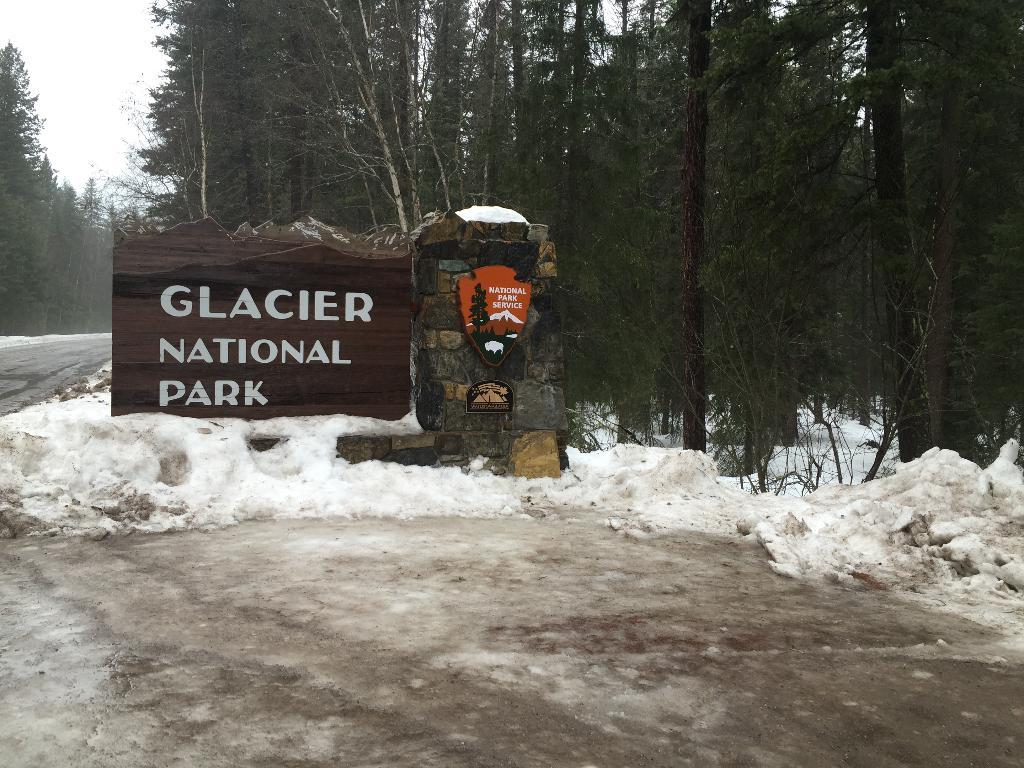What can be seen in abundance in the image? There are many trees in the image. What information is displayed in the image? The name of the park board is visible. What architectural feature is present in the image? There is a pillar in the image. What type of pathway is present in the image? A road is present in the image. What weather condition is depicted in the image? Snow is visible in the image. What part of the natural environment is visible in the image? The sky is visible in the image. What type of sign is visible at the party in the image? There is no party or sign present in the image. What emotion is expressed by the person in the image due to regret? There is no person or emotion related to regret depicted in the image. 